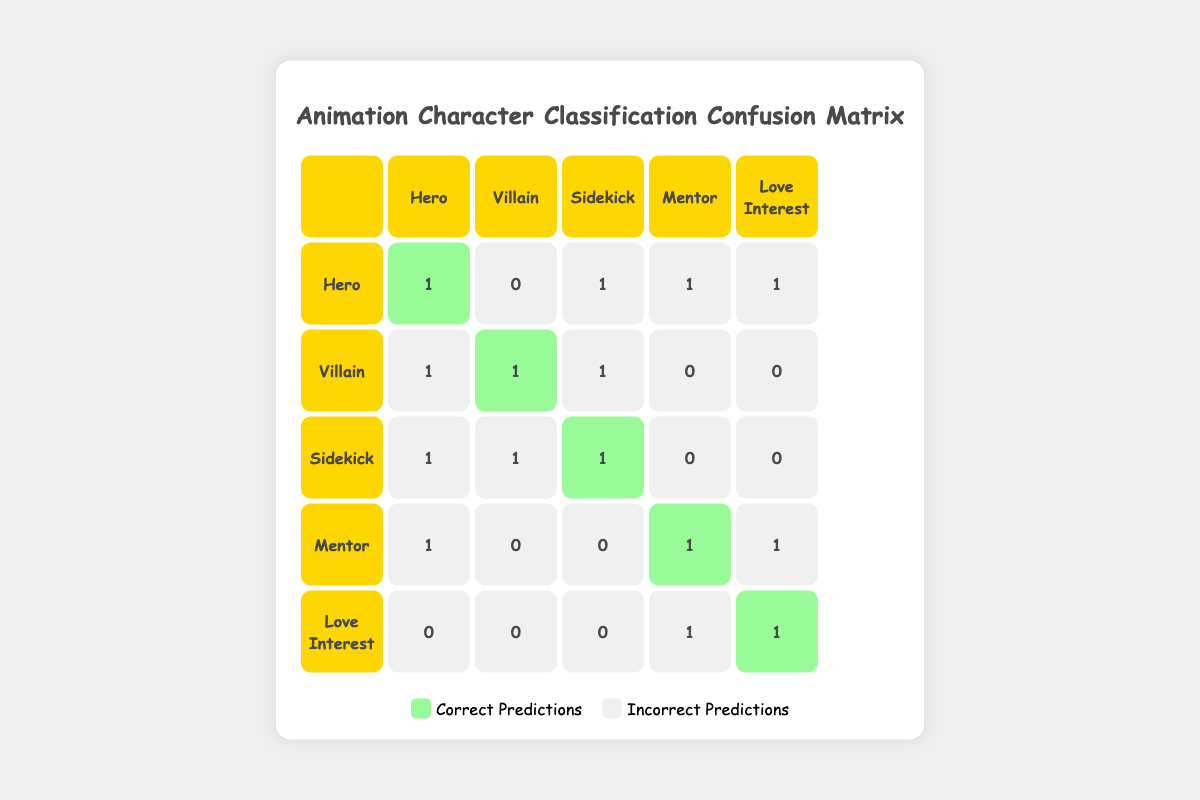What is the number of correct predictions for the Hero character type? The Hero character type is represented in the diagonal of the table, where the value is 1. Therefore, the number of correct predictions for the Hero is 1.
Answer: 1 How many times was the Villain incorrectly predicted as a Hero? We look at the Villain row and identify the Hero column; it indicates 1 incorrect prediction. This means the Villain was predicted as Hero once.
Answer: 1 What is the total number of incorrect predictions overall? To find the total number of incorrect predictions, we can sum all the non-diagonal values in the table. This gives us 1 (Hero predicted as Sidekick) + 1 (Hero as Love Interest) + 1 (Sidekick as Villain) + 1 (Villain as Hero) + 1 (Mentor as Hero) + 1 (Love Interest as Mentor) + 1 (Villain as Sidekick) + 1 (Sidekick as Hero), which equals 8.
Answer: 8 Is the Love Interest character type ever predicted correctly? The Love Interest row in the table indicates the value in the diagonal is 1, which shows that the Love Interest type was predicted correctly once.
Answer: Yes Which character type had the highest number of incorrect predictions? By examining each row, we see that the Hero and the Sidekick each have 4 incorrect predictions (as noted in their respective rows). No other character types exceed this amount.
Answer: Hero and Sidekick What is the percentage of correct predictions for the Mentor character type? The Mentor character type was predicted correctly once (the diagonal value), and it appears in the table a total of 5 times (one for each category). To find the percentage, we use the formula (correct predictions/total predictions) * 100, which results in (1/5) * 100 = 20%.
Answer: 20% What is the total number of predictions made for the Sidekick character type? To calculate the total predictions for Sidekick, we count the sidekick row as it includes both correct (1 on the diagonal) and incorrect predictions (1 predicting it as villain and 1 predicting it as hero) summing up to 3.
Answer: 3 Was the Mentor character ever misclassified as a Love Interest? In the table, we can see from the Mentor row that the value under the Love Interest column is 1, indicating that the Mentor character was indeed misclassified as a Love Interest once.
Answer: Yes How many characters had 2 or more incorrect predictions? By reviewing each row for the number of incorrect predictions, we find that Hero (4), Villain (3), and Sidekick (2) all have 2 or more incorrect predictions. The total character types with 2 or more incorrect predictions are three.
Answer: 3 